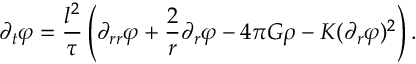<formula> <loc_0><loc_0><loc_500><loc_500>\partial _ { t } \varphi = \frac { l ^ { 2 } } { \tau } \left ( \partial _ { r r } \varphi + \frac { 2 } { r } \partial _ { r } \varphi - 4 \pi G \rho - K ( \partial _ { r } \varphi ) ^ { 2 } \right ) .</formula> 